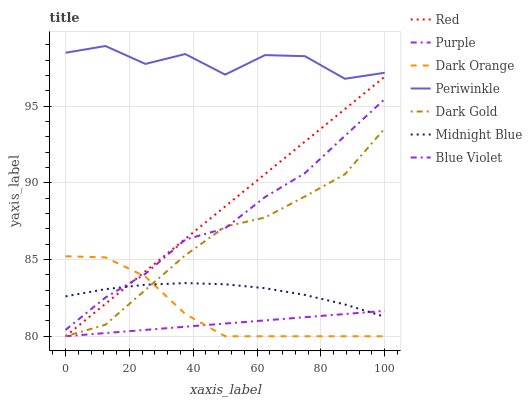Does Purple have the minimum area under the curve?
Answer yes or no. Yes. Does Periwinkle have the maximum area under the curve?
Answer yes or no. Yes. Does Midnight Blue have the minimum area under the curve?
Answer yes or no. No. Does Midnight Blue have the maximum area under the curve?
Answer yes or no. No. Is Red the smoothest?
Answer yes or no. Yes. Is Periwinkle the roughest?
Answer yes or no. Yes. Is Midnight Blue the smoothest?
Answer yes or no. No. Is Midnight Blue the roughest?
Answer yes or no. No. Does Dark Orange have the lowest value?
Answer yes or no. Yes. Does Midnight Blue have the lowest value?
Answer yes or no. No. Does Periwinkle have the highest value?
Answer yes or no. Yes. Does Midnight Blue have the highest value?
Answer yes or no. No. Is Dark Orange less than Periwinkle?
Answer yes or no. Yes. Is Periwinkle greater than Blue Violet?
Answer yes or no. Yes. Does Dark Gold intersect Purple?
Answer yes or no. Yes. Is Dark Gold less than Purple?
Answer yes or no. No. Is Dark Gold greater than Purple?
Answer yes or no. No. Does Dark Orange intersect Periwinkle?
Answer yes or no. No. 